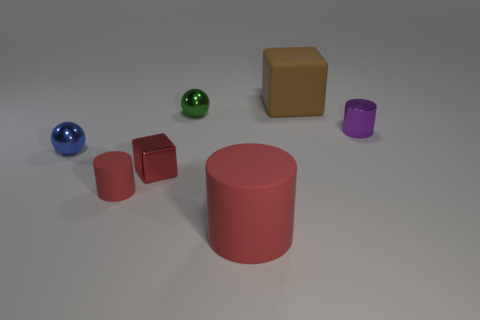What materials do the objects appear to be made of based on their surfaces? Based on their surfaces, the objects seem to have different materials. The cylinders and cubes have a matte finish, suggesting they might be made of plastic or a similar substance. The spheres, on the other hand, have a reflective surface, indicating that they could be made of a polished metal or a glossy painted material. 